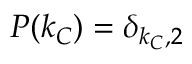Convert formula to latex. <formula><loc_0><loc_0><loc_500><loc_500>P ( k _ { C } ) = \delta _ { k _ { C } , 2 }</formula> 